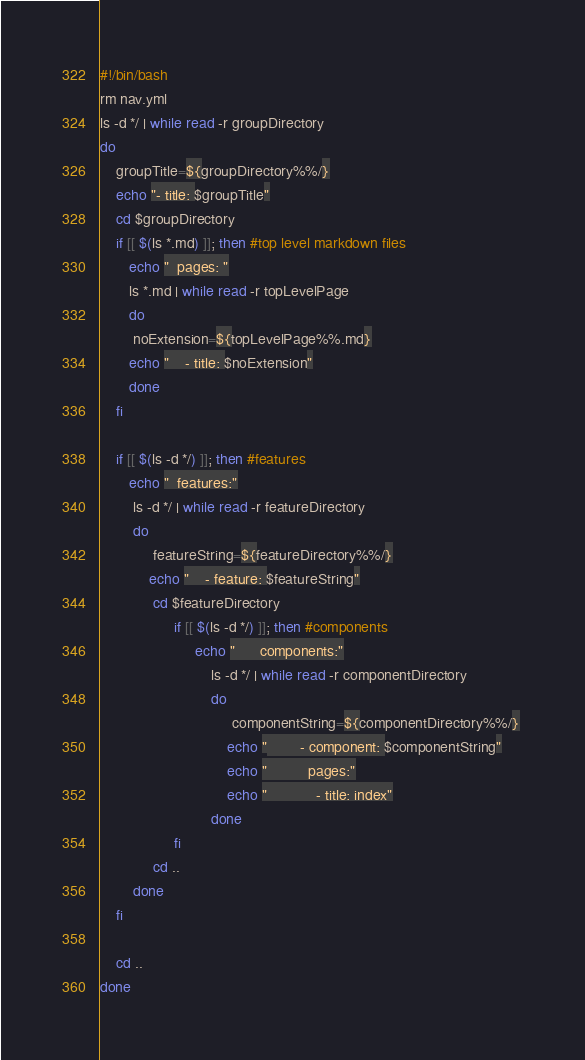Convert code to text. <code><loc_0><loc_0><loc_500><loc_500><_Bash_>#!/bin/bash
rm nav.yml
ls -d */ | while read -r groupDirectory
do
    groupTitle=${groupDirectory%%/}
    echo "- title: $groupTitle"
    cd $groupDirectory
    if [[ $(ls *.md) ]]; then #top level markdown files
       echo "  pages: "
       ls *.md | while read -r topLevelPage
       do
        noExtension=${topLevelPage%%.md}
       echo "    - title: $noExtension" 
       done
    fi

    if [[ $(ls -d */) ]]; then #features
       echo "  features:"
        ls -d */ | while read -r featureDirectory
        do
             featureString=${featureDirectory%%/} 
            echo "    - feature: $featureString" 
             cd $featureDirectory
                  if [[ $(ls -d */) ]]; then #components
                       echo "      components:"
                           ls -d */ | while read -r componentDirectory
                           do
                                componentString=${componentDirectory%%/} 
                               echo "        - component: $componentString"
                               echo "          pages:" 
                               echo "            - title: index"
                           done
                  fi
             cd ..
        done
    fi
    
    cd ..
done


</code> 